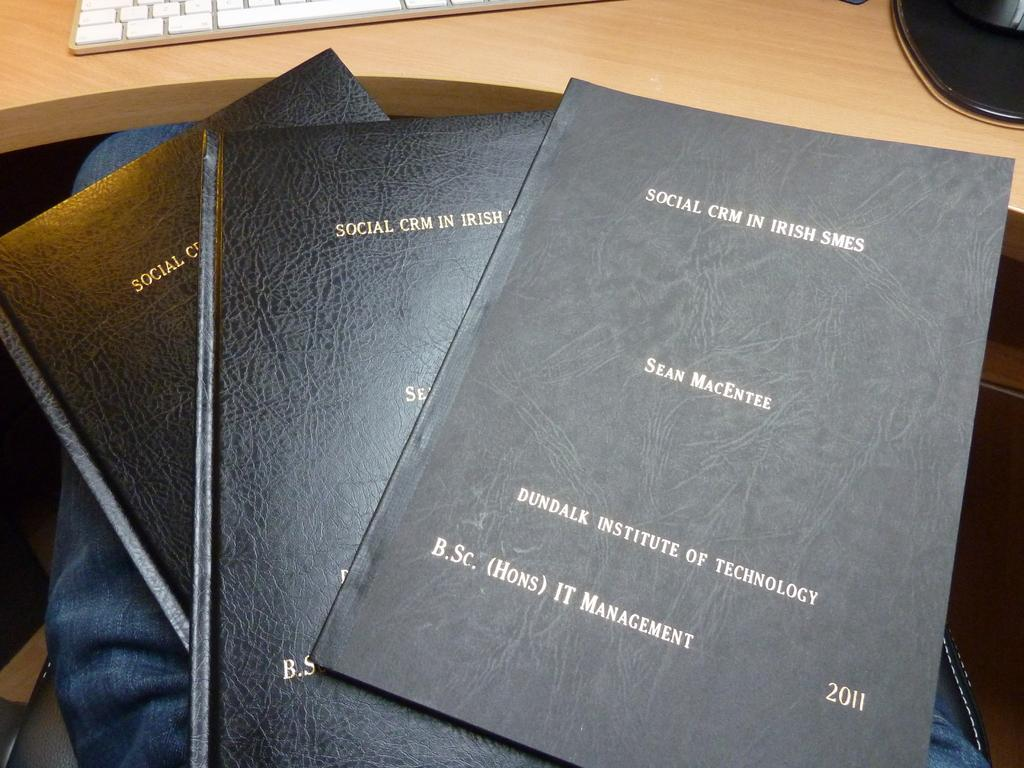What type of objects can be seen in the image? There are books and a keyboard in the image. What is the color of the books? The books are black in color. Where are the objects located in the image? The objects are on a brown color table in the image. What type of lock is present on the keyboard in the image? There is no lock present on the keyboard in the image. What type of thing is missing from the image? There is no information provided about anything missing from the image. 